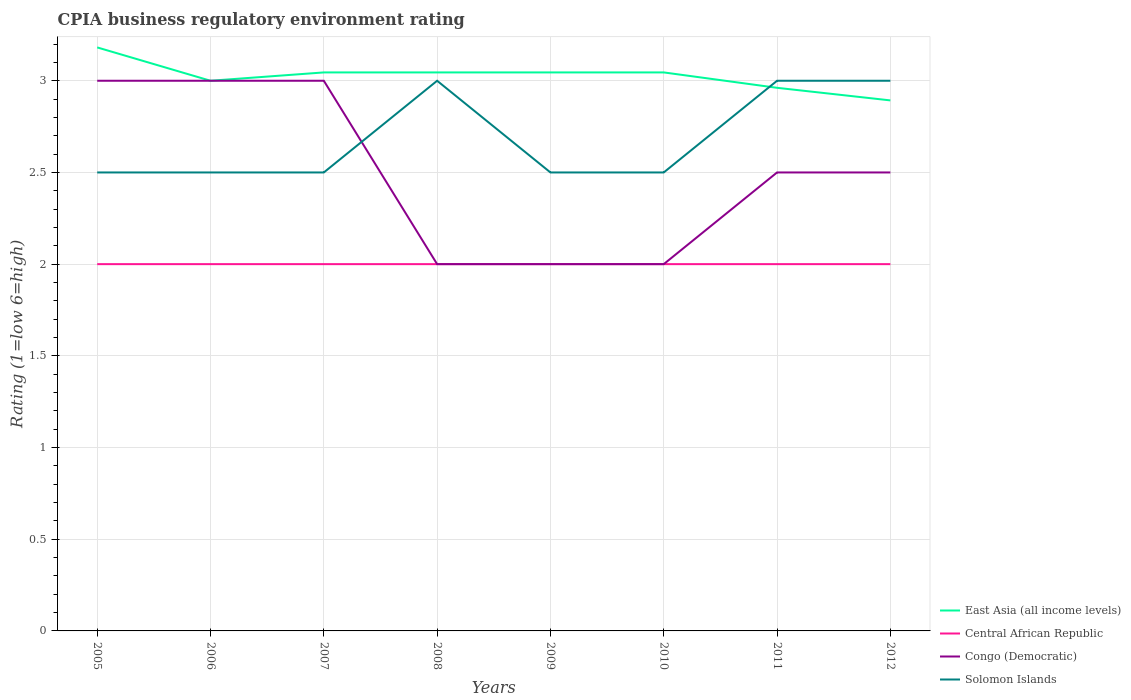How many different coloured lines are there?
Your answer should be compact. 4. Does the line corresponding to Solomon Islands intersect with the line corresponding to East Asia (all income levels)?
Your answer should be compact. Yes. Is the number of lines equal to the number of legend labels?
Your answer should be very brief. Yes. Across all years, what is the maximum CPIA rating in Central African Republic?
Keep it short and to the point. 2. In which year was the CPIA rating in Solomon Islands maximum?
Ensure brevity in your answer.  2005. What is the total CPIA rating in East Asia (all income levels) in the graph?
Your answer should be very brief. -0.05. What is the difference between the highest and the lowest CPIA rating in Solomon Islands?
Keep it short and to the point. 3. Is the CPIA rating in Solomon Islands strictly greater than the CPIA rating in Congo (Democratic) over the years?
Make the answer very short. No. Does the graph contain any zero values?
Give a very brief answer. No. Does the graph contain grids?
Offer a terse response. Yes. What is the title of the graph?
Provide a short and direct response. CPIA business regulatory environment rating. Does "Sri Lanka" appear as one of the legend labels in the graph?
Provide a succinct answer. No. What is the Rating (1=low 6=high) of East Asia (all income levels) in 2005?
Your answer should be very brief. 3.18. What is the Rating (1=low 6=high) of Solomon Islands in 2005?
Your answer should be very brief. 2.5. What is the Rating (1=low 6=high) of East Asia (all income levels) in 2006?
Provide a short and direct response. 3. What is the Rating (1=low 6=high) in Congo (Democratic) in 2006?
Provide a short and direct response. 3. What is the Rating (1=low 6=high) in Solomon Islands in 2006?
Your response must be concise. 2.5. What is the Rating (1=low 6=high) of East Asia (all income levels) in 2007?
Give a very brief answer. 3.05. What is the Rating (1=low 6=high) of Solomon Islands in 2007?
Offer a very short reply. 2.5. What is the Rating (1=low 6=high) of East Asia (all income levels) in 2008?
Your response must be concise. 3.05. What is the Rating (1=low 6=high) in Central African Republic in 2008?
Offer a very short reply. 2. What is the Rating (1=low 6=high) in Congo (Democratic) in 2008?
Your answer should be very brief. 2. What is the Rating (1=low 6=high) in East Asia (all income levels) in 2009?
Keep it short and to the point. 3.05. What is the Rating (1=low 6=high) in East Asia (all income levels) in 2010?
Keep it short and to the point. 3.05. What is the Rating (1=low 6=high) of Solomon Islands in 2010?
Your answer should be compact. 2.5. What is the Rating (1=low 6=high) in East Asia (all income levels) in 2011?
Offer a terse response. 2.96. What is the Rating (1=low 6=high) of East Asia (all income levels) in 2012?
Offer a terse response. 2.89. What is the Rating (1=low 6=high) in Central African Republic in 2012?
Ensure brevity in your answer.  2. What is the Rating (1=low 6=high) in Solomon Islands in 2012?
Keep it short and to the point. 3. Across all years, what is the maximum Rating (1=low 6=high) in East Asia (all income levels)?
Offer a terse response. 3.18. Across all years, what is the maximum Rating (1=low 6=high) of Central African Republic?
Make the answer very short. 2. Across all years, what is the maximum Rating (1=low 6=high) in Congo (Democratic)?
Your response must be concise. 3. Across all years, what is the minimum Rating (1=low 6=high) in East Asia (all income levels)?
Offer a very short reply. 2.89. Across all years, what is the minimum Rating (1=low 6=high) of Central African Republic?
Give a very brief answer. 2. What is the total Rating (1=low 6=high) of East Asia (all income levels) in the graph?
Provide a short and direct response. 24.22. What is the total Rating (1=low 6=high) in Central African Republic in the graph?
Give a very brief answer. 16. What is the difference between the Rating (1=low 6=high) of East Asia (all income levels) in 2005 and that in 2006?
Offer a very short reply. 0.18. What is the difference between the Rating (1=low 6=high) in Congo (Democratic) in 2005 and that in 2006?
Offer a terse response. 0. What is the difference between the Rating (1=low 6=high) of East Asia (all income levels) in 2005 and that in 2007?
Make the answer very short. 0.14. What is the difference between the Rating (1=low 6=high) in Central African Republic in 2005 and that in 2007?
Provide a short and direct response. 0. What is the difference between the Rating (1=low 6=high) of Congo (Democratic) in 2005 and that in 2007?
Your answer should be compact. 0. What is the difference between the Rating (1=low 6=high) in East Asia (all income levels) in 2005 and that in 2008?
Make the answer very short. 0.14. What is the difference between the Rating (1=low 6=high) of Solomon Islands in 2005 and that in 2008?
Provide a succinct answer. -0.5. What is the difference between the Rating (1=low 6=high) in East Asia (all income levels) in 2005 and that in 2009?
Your answer should be very brief. 0.14. What is the difference between the Rating (1=low 6=high) of Central African Republic in 2005 and that in 2009?
Give a very brief answer. 0. What is the difference between the Rating (1=low 6=high) of Congo (Democratic) in 2005 and that in 2009?
Keep it short and to the point. 1. What is the difference between the Rating (1=low 6=high) of Solomon Islands in 2005 and that in 2009?
Ensure brevity in your answer.  0. What is the difference between the Rating (1=low 6=high) in East Asia (all income levels) in 2005 and that in 2010?
Offer a very short reply. 0.14. What is the difference between the Rating (1=low 6=high) of East Asia (all income levels) in 2005 and that in 2011?
Offer a very short reply. 0.22. What is the difference between the Rating (1=low 6=high) of Solomon Islands in 2005 and that in 2011?
Provide a succinct answer. -0.5. What is the difference between the Rating (1=low 6=high) in East Asia (all income levels) in 2005 and that in 2012?
Keep it short and to the point. 0.29. What is the difference between the Rating (1=low 6=high) of Congo (Democratic) in 2005 and that in 2012?
Your answer should be very brief. 0.5. What is the difference between the Rating (1=low 6=high) in Solomon Islands in 2005 and that in 2012?
Your answer should be very brief. -0.5. What is the difference between the Rating (1=low 6=high) in East Asia (all income levels) in 2006 and that in 2007?
Your answer should be compact. -0.05. What is the difference between the Rating (1=low 6=high) of Central African Republic in 2006 and that in 2007?
Keep it short and to the point. 0. What is the difference between the Rating (1=low 6=high) of Congo (Democratic) in 2006 and that in 2007?
Offer a very short reply. 0. What is the difference between the Rating (1=low 6=high) of East Asia (all income levels) in 2006 and that in 2008?
Your response must be concise. -0.05. What is the difference between the Rating (1=low 6=high) of Congo (Democratic) in 2006 and that in 2008?
Your answer should be compact. 1. What is the difference between the Rating (1=low 6=high) in Solomon Islands in 2006 and that in 2008?
Give a very brief answer. -0.5. What is the difference between the Rating (1=low 6=high) in East Asia (all income levels) in 2006 and that in 2009?
Ensure brevity in your answer.  -0.05. What is the difference between the Rating (1=low 6=high) of Central African Republic in 2006 and that in 2009?
Offer a very short reply. 0. What is the difference between the Rating (1=low 6=high) in Congo (Democratic) in 2006 and that in 2009?
Ensure brevity in your answer.  1. What is the difference between the Rating (1=low 6=high) of Solomon Islands in 2006 and that in 2009?
Give a very brief answer. 0. What is the difference between the Rating (1=low 6=high) of East Asia (all income levels) in 2006 and that in 2010?
Your answer should be compact. -0.05. What is the difference between the Rating (1=low 6=high) in Central African Republic in 2006 and that in 2010?
Ensure brevity in your answer.  0. What is the difference between the Rating (1=low 6=high) of East Asia (all income levels) in 2006 and that in 2011?
Your response must be concise. 0.04. What is the difference between the Rating (1=low 6=high) of Central African Republic in 2006 and that in 2011?
Your answer should be compact. 0. What is the difference between the Rating (1=low 6=high) in Congo (Democratic) in 2006 and that in 2011?
Your answer should be compact. 0.5. What is the difference between the Rating (1=low 6=high) of Solomon Islands in 2006 and that in 2011?
Offer a very short reply. -0.5. What is the difference between the Rating (1=low 6=high) in East Asia (all income levels) in 2006 and that in 2012?
Your answer should be very brief. 0.11. What is the difference between the Rating (1=low 6=high) of Solomon Islands in 2006 and that in 2012?
Ensure brevity in your answer.  -0.5. What is the difference between the Rating (1=low 6=high) of East Asia (all income levels) in 2007 and that in 2008?
Your answer should be very brief. 0. What is the difference between the Rating (1=low 6=high) of Solomon Islands in 2007 and that in 2008?
Give a very brief answer. -0.5. What is the difference between the Rating (1=low 6=high) of Central African Republic in 2007 and that in 2009?
Give a very brief answer. 0. What is the difference between the Rating (1=low 6=high) in Congo (Democratic) in 2007 and that in 2009?
Ensure brevity in your answer.  1. What is the difference between the Rating (1=low 6=high) of Solomon Islands in 2007 and that in 2009?
Your response must be concise. 0. What is the difference between the Rating (1=low 6=high) of East Asia (all income levels) in 2007 and that in 2010?
Make the answer very short. 0. What is the difference between the Rating (1=low 6=high) of Congo (Democratic) in 2007 and that in 2010?
Give a very brief answer. 1. What is the difference between the Rating (1=low 6=high) of Solomon Islands in 2007 and that in 2010?
Keep it short and to the point. 0. What is the difference between the Rating (1=low 6=high) of East Asia (all income levels) in 2007 and that in 2011?
Provide a short and direct response. 0.08. What is the difference between the Rating (1=low 6=high) of Congo (Democratic) in 2007 and that in 2011?
Ensure brevity in your answer.  0.5. What is the difference between the Rating (1=low 6=high) in East Asia (all income levels) in 2007 and that in 2012?
Your answer should be compact. 0.15. What is the difference between the Rating (1=low 6=high) of Congo (Democratic) in 2007 and that in 2012?
Offer a terse response. 0.5. What is the difference between the Rating (1=low 6=high) of Solomon Islands in 2007 and that in 2012?
Your answer should be very brief. -0.5. What is the difference between the Rating (1=low 6=high) in East Asia (all income levels) in 2008 and that in 2009?
Provide a short and direct response. 0. What is the difference between the Rating (1=low 6=high) in Central African Republic in 2008 and that in 2009?
Provide a succinct answer. 0. What is the difference between the Rating (1=low 6=high) of Congo (Democratic) in 2008 and that in 2009?
Ensure brevity in your answer.  0. What is the difference between the Rating (1=low 6=high) of Solomon Islands in 2008 and that in 2009?
Offer a terse response. 0.5. What is the difference between the Rating (1=low 6=high) in East Asia (all income levels) in 2008 and that in 2010?
Provide a succinct answer. 0. What is the difference between the Rating (1=low 6=high) of Congo (Democratic) in 2008 and that in 2010?
Make the answer very short. 0. What is the difference between the Rating (1=low 6=high) of Solomon Islands in 2008 and that in 2010?
Your answer should be compact. 0.5. What is the difference between the Rating (1=low 6=high) in East Asia (all income levels) in 2008 and that in 2011?
Your answer should be very brief. 0.08. What is the difference between the Rating (1=low 6=high) in East Asia (all income levels) in 2008 and that in 2012?
Give a very brief answer. 0.15. What is the difference between the Rating (1=low 6=high) in Congo (Democratic) in 2008 and that in 2012?
Ensure brevity in your answer.  -0.5. What is the difference between the Rating (1=low 6=high) in East Asia (all income levels) in 2009 and that in 2010?
Your response must be concise. 0. What is the difference between the Rating (1=low 6=high) of East Asia (all income levels) in 2009 and that in 2011?
Give a very brief answer. 0.08. What is the difference between the Rating (1=low 6=high) of Central African Republic in 2009 and that in 2011?
Offer a very short reply. 0. What is the difference between the Rating (1=low 6=high) of Solomon Islands in 2009 and that in 2011?
Your answer should be very brief. -0.5. What is the difference between the Rating (1=low 6=high) in East Asia (all income levels) in 2009 and that in 2012?
Give a very brief answer. 0.15. What is the difference between the Rating (1=low 6=high) in Central African Republic in 2009 and that in 2012?
Your answer should be compact. 0. What is the difference between the Rating (1=low 6=high) of Congo (Democratic) in 2009 and that in 2012?
Provide a succinct answer. -0.5. What is the difference between the Rating (1=low 6=high) of Solomon Islands in 2009 and that in 2012?
Ensure brevity in your answer.  -0.5. What is the difference between the Rating (1=low 6=high) in East Asia (all income levels) in 2010 and that in 2011?
Keep it short and to the point. 0.08. What is the difference between the Rating (1=low 6=high) of East Asia (all income levels) in 2010 and that in 2012?
Keep it short and to the point. 0.15. What is the difference between the Rating (1=low 6=high) of Central African Republic in 2010 and that in 2012?
Make the answer very short. 0. What is the difference between the Rating (1=low 6=high) in Solomon Islands in 2010 and that in 2012?
Provide a succinct answer. -0.5. What is the difference between the Rating (1=low 6=high) in East Asia (all income levels) in 2011 and that in 2012?
Ensure brevity in your answer.  0.07. What is the difference between the Rating (1=low 6=high) in East Asia (all income levels) in 2005 and the Rating (1=low 6=high) in Central African Republic in 2006?
Offer a very short reply. 1.18. What is the difference between the Rating (1=low 6=high) in East Asia (all income levels) in 2005 and the Rating (1=low 6=high) in Congo (Democratic) in 2006?
Offer a very short reply. 0.18. What is the difference between the Rating (1=low 6=high) in East Asia (all income levels) in 2005 and the Rating (1=low 6=high) in Solomon Islands in 2006?
Provide a short and direct response. 0.68. What is the difference between the Rating (1=low 6=high) of Central African Republic in 2005 and the Rating (1=low 6=high) of Solomon Islands in 2006?
Keep it short and to the point. -0.5. What is the difference between the Rating (1=low 6=high) in East Asia (all income levels) in 2005 and the Rating (1=low 6=high) in Central African Republic in 2007?
Your answer should be very brief. 1.18. What is the difference between the Rating (1=low 6=high) in East Asia (all income levels) in 2005 and the Rating (1=low 6=high) in Congo (Democratic) in 2007?
Give a very brief answer. 0.18. What is the difference between the Rating (1=low 6=high) in East Asia (all income levels) in 2005 and the Rating (1=low 6=high) in Solomon Islands in 2007?
Ensure brevity in your answer.  0.68. What is the difference between the Rating (1=low 6=high) in Central African Republic in 2005 and the Rating (1=low 6=high) in Solomon Islands in 2007?
Provide a short and direct response. -0.5. What is the difference between the Rating (1=low 6=high) of Congo (Democratic) in 2005 and the Rating (1=low 6=high) of Solomon Islands in 2007?
Your response must be concise. 0.5. What is the difference between the Rating (1=low 6=high) in East Asia (all income levels) in 2005 and the Rating (1=low 6=high) in Central African Republic in 2008?
Keep it short and to the point. 1.18. What is the difference between the Rating (1=low 6=high) in East Asia (all income levels) in 2005 and the Rating (1=low 6=high) in Congo (Democratic) in 2008?
Your response must be concise. 1.18. What is the difference between the Rating (1=low 6=high) of East Asia (all income levels) in 2005 and the Rating (1=low 6=high) of Solomon Islands in 2008?
Keep it short and to the point. 0.18. What is the difference between the Rating (1=low 6=high) of Central African Republic in 2005 and the Rating (1=low 6=high) of Congo (Democratic) in 2008?
Provide a succinct answer. 0. What is the difference between the Rating (1=low 6=high) in Congo (Democratic) in 2005 and the Rating (1=low 6=high) in Solomon Islands in 2008?
Give a very brief answer. 0. What is the difference between the Rating (1=low 6=high) in East Asia (all income levels) in 2005 and the Rating (1=low 6=high) in Central African Republic in 2009?
Your answer should be compact. 1.18. What is the difference between the Rating (1=low 6=high) in East Asia (all income levels) in 2005 and the Rating (1=low 6=high) in Congo (Democratic) in 2009?
Give a very brief answer. 1.18. What is the difference between the Rating (1=low 6=high) in East Asia (all income levels) in 2005 and the Rating (1=low 6=high) in Solomon Islands in 2009?
Keep it short and to the point. 0.68. What is the difference between the Rating (1=low 6=high) of Central African Republic in 2005 and the Rating (1=low 6=high) of Congo (Democratic) in 2009?
Your response must be concise. 0. What is the difference between the Rating (1=low 6=high) of Central African Republic in 2005 and the Rating (1=low 6=high) of Solomon Islands in 2009?
Offer a terse response. -0.5. What is the difference between the Rating (1=low 6=high) of East Asia (all income levels) in 2005 and the Rating (1=low 6=high) of Central African Republic in 2010?
Provide a succinct answer. 1.18. What is the difference between the Rating (1=low 6=high) of East Asia (all income levels) in 2005 and the Rating (1=low 6=high) of Congo (Democratic) in 2010?
Offer a terse response. 1.18. What is the difference between the Rating (1=low 6=high) in East Asia (all income levels) in 2005 and the Rating (1=low 6=high) in Solomon Islands in 2010?
Your answer should be very brief. 0.68. What is the difference between the Rating (1=low 6=high) of Central African Republic in 2005 and the Rating (1=low 6=high) of Congo (Democratic) in 2010?
Provide a short and direct response. 0. What is the difference between the Rating (1=low 6=high) of Central African Republic in 2005 and the Rating (1=low 6=high) of Solomon Islands in 2010?
Your answer should be very brief. -0.5. What is the difference between the Rating (1=low 6=high) in East Asia (all income levels) in 2005 and the Rating (1=low 6=high) in Central African Republic in 2011?
Your answer should be very brief. 1.18. What is the difference between the Rating (1=low 6=high) of East Asia (all income levels) in 2005 and the Rating (1=low 6=high) of Congo (Democratic) in 2011?
Ensure brevity in your answer.  0.68. What is the difference between the Rating (1=low 6=high) of East Asia (all income levels) in 2005 and the Rating (1=low 6=high) of Solomon Islands in 2011?
Your response must be concise. 0.18. What is the difference between the Rating (1=low 6=high) in Central African Republic in 2005 and the Rating (1=low 6=high) in Solomon Islands in 2011?
Offer a terse response. -1. What is the difference between the Rating (1=low 6=high) of Congo (Democratic) in 2005 and the Rating (1=low 6=high) of Solomon Islands in 2011?
Offer a terse response. 0. What is the difference between the Rating (1=low 6=high) in East Asia (all income levels) in 2005 and the Rating (1=low 6=high) in Central African Republic in 2012?
Provide a short and direct response. 1.18. What is the difference between the Rating (1=low 6=high) in East Asia (all income levels) in 2005 and the Rating (1=low 6=high) in Congo (Democratic) in 2012?
Provide a succinct answer. 0.68. What is the difference between the Rating (1=low 6=high) of East Asia (all income levels) in 2005 and the Rating (1=low 6=high) of Solomon Islands in 2012?
Your answer should be compact. 0.18. What is the difference between the Rating (1=low 6=high) in Congo (Democratic) in 2005 and the Rating (1=low 6=high) in Solomon Islands in 2012?
Keep it short and to the point. 0. What is the difference between the Rating (1=low 6=high) of East Asia (all income levels) in 2006 and the Rating (1=low 6=high) of Central African Republic in 2007?
Ensure brevity in your answer.  1. What is the difference between the Rating (1=low 6=high) in East Asia (all income levels) in 2006 and the Rating (1=low 6=high) in Congo (Democratic) in 2007?
Provide a short and direct response. 0. What is the difference between the Rating (1=low 6=high) of East Asia (all income levels) in 2006 and the Rating (1=low 6=high) of Solomon Islands in 2007?
Ensure brevity in your answer.  0.5. What is the difference between the Rating (1=low 6=high) of Central African Republic in 2006 and the Rating (1=low 6=high) of Congo (Democratic) in 2007?
Offer a terse response. -1. What is the difference between the Rating (1=low 6=high) of Congo (Democratic) in 2006 and the Rating (1=low 6=high) of Solomon Islands in 2007?
Offer a very short reply. 0.5. What is the difference between the Rating (1=low 6=high) in East Asia (all income levels) in 2006 and the Rating (1=low 6=high) in Central African Republic in 2008?
Your answer should be compact. 1. What is the difference between the Rating (1=low 6=high) in East Asia (all income levels) in 2006 and the Rating (1=low 6=high) in Congo (Democratic) in 2008?
Make the answer very short. 1. What is the difference between the Rating (1=low 6=high) in East Asia (all income levels) in 2006 and the Rating (1=low 6=high) in Solomon Islands in 2008?
Offer a terse response. 0. What is the difference between the Rating (1=low 6=high) in Central African Republic in 2006 and the Rating (1=low 6=high) in Congo (Democratic) in 2008?
Your answer should be compact. 0. What is the difference between the Rating (1=low 6=high) of Central African Republic in 2006 and the Rating (1=low 6=high) of Solomon Islands in 2008?
Make the answer very short. -1. What is the difference between the Rating (1=low 6=high) in Congo (Democratic) in 2006 and the Rating (1=low 6=high) in Solomon Islands in 2008?
Provide a short and direct response. 0. What is the difference between the Rating (1=low 6=high) of East Asia (all income levels) in 2006 and the Rating (1=low 6=high) of Central African Republic in 2009?
Your answer should be very brief. 1. What is the difference between the Rating (1=low 6=high) in East Asia (all income levels) in 2006 and the Rating (1=low 6=high) in Congo (Democratic) in 2009?
Make the answer very short. 1. What is the difference between the Rating (1=low 6=high) in Central African Republic in 2006 and the Rating (1=low 6=high) in Solomon Islands in 2009?
Give a very brief answer. -0.5. What is the difference between the Rating (1=low 6=high) in East Asia (all income levels) in 2006 and the Rating (1=low 6=high) in Central African Republic in 2010?
Offer a very short reply. 1. What is the difference between the Rating (1=low 6=high) of East Asia (all income levels) in 2006 and the Rating (1=low 6=high) of Central African Republic in 2011?
Keep it short and to the point. 1. What is the difference between the Rating (1=low 6=high) in East Asia (all income levels) in 2006 and the Rating (1=low 6=high) in Solomon Islands in 2011?
Offer a terse response. 0. What is the difference between the Rating (1=low 6=high) of Central African Republic in 2006 and the Rating (1=low 6=high) of Congo (Democratic) in 2011?
Give a very brief answer. -0.5. What is the difference between the Rating (1=low 6=high) in Congo (Democratic) in 2006 and the Rating (1=low 6=high) in Solomon Islands in 2011?
Offer a very short reply. 0. What is the difference between the Rating (1=low 6=high) in East Asia (all income levels) in 2006 and the Rating (1=low 6=high) in Central African Republic in 2012?
Give a very brief answer. 1. What is the difference between the Rating (1=low 6=high) in East Asia (all income levels) in 2006 and the Rating (1=low 6=high) in Congo (Democratic) in 2012?
Your answer should be compact. 0.5. What is the difference between the Rating (1=low 6=high) in Central African Republic in 2006 and the Rating (1=low 6=high) in Congo (Democratic) in 2012?
Offer a terse response. -0.5. What is the difference between the Rating (1=low 6=high) in Central African Republic in 2006 and the Rating (1=low 6=high) in Solomon Islands in 2012?
Your response must be concise. -1. What is the difference between the Rating (1=low 6=high) in Congo (Democratic) in 2006 and the Rating (1=low 6=high) in Solomon Islands in 2012?
Provide a succinct answer. 0. What is the difference between the Rating (1=low 6=high) of East Asia (all income levels) in 2007 and the Rating (1=low 6=high) of Central African Republic in 2008?
Give a very brief answer. 1.05. What is the difference between the Rating (1=low 6=high) of East Asia (all income levels) in 2007 and the Rating (1=low 6=high) of Congo (Democratic) in 2008?
Make the answer very short. 1.05. What is the difference between the Rating (1=low 6=high) of East Asia (all income levels) in 2007 and the Rating (1=low 6=high) of Solomon Islands in 2008?
Offer a very short reply. 0.05. What is the difference between the Rating (1=low 6=high) of Central African Republic in 2007 and the Rating (1=low 6=high) of Solomon Islands in 2008?
Your response must be concise. -1. What is the difference between the Rating (1=low 6=high) of East Asia (all income levels) in 2007 and the Rating (1=low 6=high) of Central African Republic in 2009?
Give a very brief answer. 1.05. What is the difference between the Rating (1=low 6=high) in East Asia (all income levels) in 2007 and the Rating (1=low 6=high) in Congo (Democratic) in 2009?
Ensure brevity in your answer.  1.05. What is the difference between the Rating (1=low 6=high) in East Asia (all income levels) in 2007 and the Rating (1=low 6=high) in Solomon Islands in 2009?
Your response must be concise. 0.55. What is the difference between the Rating (1=low 6=high) in Congo (Democratic) in 2007 and the Rating (1=low 6=high) in Solomon Islands in 2009?
Provide a succinct answer. 0.5. What is the difference between the Rating (1=low 6=high) in East Asia (all income levels) in 2007 and the Rating (1=low 6=high) in Central African Republic in 2010?
Ensure brevity in your answer.  1.05. What is the difference between the Rating (1=low 6=high) of East Asia (all income levels) in 2007 and the Rating (1=low 6=high) of Congo (Democratic) in 2010?
Ensure brevity in your answer.  1.05. What is the difference between the Rating (1=low 6=high) in East Asia (all income levels) in 2007 and the Rating (1=low 6=high) in Solomon Islands in 2010?
Offer a terse response. 0.55. What is the difference between the Rating (1=low 6=high) of Central African Republic in 2007 and the Rating (1=low 6=high) of Congo (Democratic) in 2010?
Keep it short and to the point. 0. What is the difference between the Rating (1=low 6=high) of Central African Republic in 2007 and the Rating (1=low 6=high) of Solomon Islands in 2010?
Provide a succinct answer. -0.5. What is the difference between the Rating (1=low 6=high) of Congo (Democratic) in 2007 and the Rating (1=low 6=high) of Solomon Islands in 2010?
Offer a terse response. 0.5. What is the difference between the Rating (1=low 6=high) in East Asia (all income levels) in 2007 and the Rating (1=low 6=high) in Central African Republic in 2011?
Your answer should be very brief. 1.05. What is the difference between the Rating (1=low 6=high) of East Asia (all income levels) in 2007 and the Rating (1=low 6=high) of Congo (Democratic) in 2011?
Make the answer very short. 0.55. What is the difference between the Rating (1=low 6=high) in East Asia (all income levels) in 2007 and the Rating (1=low 6=high) in Solomon Islands in 2011?
Provide a short and direct response. 0.05. What is the difference between the Rating (1=low 6=high) of East Asia (all income levels) in 2007 and the Rating (1=low 6=high) of Central African Republic in 2012?
Provide a succinct answer. 1.05. What is the difference between the Rating (1=low 6=high) of East Asia (all income levels) in 2007 and the Rating (1=low 6=high) of Congo (Democratic) in 2012?
Ensure brevity in your answer.  0.55. What is the difference between the Rating (1=low 6=high) in East Asia (all income levels) in 2007 and the Rating (1=low 6=high) in Solomon Islands in 2012?
Give a very brief answer. 0.05. What is the difference between the Rating (1=low 6=high) in Central African Republic in 2007 and the Rating (1=low 6=high) in Congo (Democratic) in 2012?
Make the answer very short. -0.5. What is the difference between the Rating (1=low 6=high) in East Asia (all income levels) in 2008 and the Rating (1=low 6=high) in Central African Republic in 2009?
Offer a very short reply. 1.05. What is the difference between the Rating (1=low 6=high) in East Asia (all income levels) in 2008 and the Rating (1=low 6=high) in Congo (Democratic) in 2009?
Offer a terse response. 1.05. What is the difference between the Rating (1=low 6=high) of East Asia (all income levels) in 2008 and the Rating (1=low 6=high) of Solomon Islands in 2009?
Your answer should be very brief. 0.55. What is the difference between the Rating (1=low 6=high) of Central African Republic in 2008 and the Rating (1=low 6=high) of Congo (Democratic) in 2009?
Ensure brevity in your answer.  0. What is the difference between the Rating (1=low 6=high) in Central African Republic in 2008 and the Rating (1=low 6=high) in Solomon Islands in 2009?
Offer a terse response. -0.5. What is the difference between the Rating (1=low 6=high) in Congo (Democratic) in 2008 and the Rating (1=low 6=high) in Solomon Islands in 2009?
Make the answer very short. -0.5. What is the difference between the Rating (1=low 6=high) in East Asia (all income levels) in 2008 and the Rating (1=low 6=high) in Central African Republic in 2010?
Provide a short and direct response. 1.05. What is the difference between the Rating (1=low 6=high) of East Asia (all income levels) in 2008 and the Rating (1=low 6=high) of Congo (Democratic) in 2010?
Provide a short and direct response. 1.05. What is the difference between the Rating (1=low 6=high) in East Asia (all income levels) in 2008 and the Rating (1=low 6=high) in Solomon Islands in 2010?
Offer a terse response. 0.55. What is the difference between the Rating (1=low 6=high) in Central African Republic in 2008 and the Rating (1=low 6=high) in Solomon Islands in 2010?
Your answer should be compact. -0.5. What is the difference between the Rating (1=low 6=high) in Congo (Democratic) in 2008 and the Rating (1=low 6=high) in Solomon Islands in 2010?
Ensure brevity in your answer.  -0.5. What is the difference between the Rating (1=low 6=high) in East Asia (all income levels) in 2008 and the Rating (1=low 6=high) in Central African Republic in 2011?
Provide a succinct answer. 1.05. What is the difference between the Rating (1=low 6=high) in East Asia (all income levels) in 2008 and the Rating (1=low 6=high) in Congo (Democratic) in 2011?
Keep it short and to the point. 0.55. What is the difference between the Rating (1=low 6=high) of East Asia (all income levels) in 2008 and the Rating (1=low 6=high) of Solomon Islands in 2011?
Offer a terse response. 0.05. What is the difference between the Rating (1=low 6=high) in Central African Republic in 2008 and the Rating (1=low 6=high) in Solomon Islands in 2011?
Your response must be concise. -1. What is the difference between the Rating (1=low 6=high) in East Asia (all income levels) in 2008 and the Rating (1=low 6=high) in Central African Republic in 2012?
Your answer should be very brief. 1.05. What is the difference between the Rating (1=low 6=high) of East Asia (all income levels) in 2008 and the Rating (1=low 6=high) of Congo (Democratic) in 2012?
Ensure brevity in your answer.  0.55. What is the difference between the Rating (1=low 6=high) of East Asia (all income levels) in 2008 and the Rating (1=low 6=high) of Solomon Islands in 2012?
Provide a succinct answer. 0.05. What is the difference between the Rating (1=low 6=high) of Central African Republic in 2008 and the Rating (1=low 6=high) of Congo (Democratic) in 2012?
Provide a short and direct response. -0.5. What is the difference between the Rating (1=low 6=high) of Central African Republic in 2008 and the Rating (1=low 6=high) of Solomon Islands in 2012?
Offer a terse response. -1. What is the difference between the Rating (1=low 6=high) of East Asia (all income levels) in 2009 and the Rating (1=low 6=high) of Central African Republic in 2010?
Keep it short and to the point. 1.05. What is the difference between the Rating (1=low 6=high) of East Asia (all income levels) in 2009 and the Rating (1=low 6=high) of Congo (Democratic) in 2010?
Make the answer very short. 1.05. What is the difference between the Rating (1=low 6=high) in East Asia (all income levels) in 2009 and the Rating (1=low 6=high) in Solomon Islands in 2010?
Keep it short and to the point. 0.55. What is the difference between the Rating (1=low 6=high) in Central African Republic in 2009 and the Rating (1=low 6=high) in Congo (Democratic) in 2010?
Your response must be concise. 0. What is the difference between the Rating (1=low 6=high) in Central African Republic in 2009 and the Rating (1=low 6=high) in Solomon Islands in 2010?
Offer a very short reply. -0.5. What is the difference between the Rating (1=low 6=high) in Congo (Democratic) in 2009 and the Rating (1=low 6=high) in Solomon Islands in 2010?
Your answer should be very brief. -0.5. What is the difference between the Rating (1=low 6=high) of East Asia (all income levels) in 2009 and the Rating (1=low 6=high) of Central African Republic in 2011?
Offer a very short reply. 1.05. What is the difference between the Rating (1=low 6=high) in East Asia (all income levels) in 2009 and the Rating (1=low 6=high) in Congo (Democratic) in 2011?
Provide a succinct answer. 0.55. What is the difference between the Rating (1=low 6=high) of East Asia (all income levels) in 2009 and the Rating (1=low 6=high) of Solomon Islands in 2011?
Ensure brevity in your answer.  0.05. What is the difference between the Rating (1=low 6=high) in Central African Republic in 2009 and the Rating (1=low 6=high) in Congo (Democratic) in 2011?
Offer a terse response. -0.5. What is the difference between the Rating (1=low 6=high) in Central African Republic in 2009 and the Rating (1=low 6=high) in Solomon Islands in 2011?
Make the answer very short. -1. What is the difference between the Rating (1=low 6=high) of Congo (Democratic) in 2009 and the Rating (1=low 6=high) of Solomon Islands in 2011?
Your answer should be very brief. -1. What is the difference between the Rating (1=low 6=high) in East Asia (all income levels) in 2009 and the Rating (1=low 6=high) in Central African Republic in 2012?
Your response must be concise. 1.05. What is the difference between the Rating (1=low 6=high) of East Asia (all income levels) in 2009 and the Rating (1=low 6=high) of Congo (Democratic) in 2012?
Your answer should be very brief. 0.55. What is the difference between the Rating (1=low 6=high) of East Asia (all income levels) in 2009 and the Rating (1=low 6=high) of Solomon Islands in 2012?
Your response must be concise. 0.05. What is the difference between the Rating (1=low 6=high) of Central African Republic in 2009 and the Rating (1=low 6=high) of Solomon Islands in 2012?
Ensure brevity in your answer.  -1. What is the difference between the Rating (1=low 6=high) in East Asia (all income levels) in 2010 and the Rating (1=low 6=high) in Central African Republic in 2011?
Give a very brief answer. 1.05. What is the difference between the Rating (1=low 6=high) of East Asia (all income levels) in 2010 and the Rating (1=low 6=high) of Congo (Democratic) in 2011?
Make the answer very short. 0.55. What is the difference between the Rating (1=low 6=high) of East Asia (all income levels) in 2010 and the Rating (1=low 6=high) of Solomon Islands in 2011?
Make the answer very short. 0.05. What is the difference between the Rating (1=low 6=high) in Central African Republic in 2010 and the Rating (1=low 6=high) in Solomon Islands in 2011?
Offer a terse response. -1. What is the difference between the Rating (1=low 6=high) in East Asia (all income levels) in 2010 and the Rating (1=low 6=high) in Central African Republic in 2012?
Provide a short and direct response. 1.05. What is the difference between the Rating (1=low 6=high) in East Asia (all income levels) in 2010 and the Rating (1=low 6=high) in Congo (Democratic) in 2012?
Offer a terse response. 0.55. What is the difference between the Rating (1=low 6=high) in East Asia (all income levels) in 2010 and the Rating (1=low 6=high) in Solomon Islands in 2012?
Provide a short and direct response. 0.05. What is the difference between the Rating (1=low 6=high) in Central African Republic in 2010 and the Rating (1=low 6=high) in Congo (Democratic) in 2012?
Your response must be concise. -0.5. What is the difference between the Rating (1=low 6=high) in East Asia (all income levels) in 2011 and the Rating (1=low 6=high) in Central African Republic in 2012?
Ensure brevity in your answer.  0.96. What is the difference between the Rating (1=low 6=high) of East Asia (all income levels) in 2011 and the Rating (1=low 6=high) of Congo (Democratic) in 2012?
Your answer should be compact. 0.46. What is the difference between the Rating (1=low 6=high) of East Asia (all income levels) in 2011 and the Rating (1=low 6=high) of Solomon Islands in 2012?
Offer a very short reply. -0.04. What is the difference between the Rating (1=low 6=high) of Central African Republic in 2011 and the Rating (1=low 6=high) of Congo (Democratic) in 2012?
Your answer should be compact. -0.5. What is the difference between the Rating (1=low 6=high) in Central African Republic in 2011 and the Rating (1=low 6=high) in Solomon Islands in 2012?
Provide a short and direct response. -1. What is the difference between the Rating (1=low 6=high) of Congo (Democratic) in 2011 and the Rating (1=low 6=high) of Solomon Islands in 2012?
Your answer should be compact. -0.5. What is the average Rating (1=low 6=high) in East Asia (all income levels) per year?
Provide a succinct answer. 3.03. What is the average Rating (1=low 6=high) in Central African Republic per year?
Give a very brief answer. 2. What is the average Rating (1=low 6=high) in Congo (Democratic) per year?
Offer a terse response. 2.5. What is the average Rating (1=low 6=high) in Solomon Islands per year?
Your answer should be very brief. 2.69. In the year 2005, what is the difference between the Rating (1=low 6=high) of East Asia (all income levels) and Rating (1=low 6=high) of Central African Republic?
Keep it short and to the point. 1.18. In the year 2005, what is the difference between the Rating (1=low 6=high) in East Asia (all income levels) and Rating (1=low 6=high) in Congo (Democratic)?
Your answer should be compact. 0.18. In the year 2005, what is the difference between the Rating (1=low 6=high) in East Asia (all income levels) and Rating (1=low 6=high) in Solomon Islands?
Offer a terse response. 0.68. In the year 2005, what is the difference between the Rating (1=low 6=high) of Central African Republic and Rating (1=low 6=high) of Solomon Islands?
Offer a terse response. -0.5. In the year 2005, what is the difference between the Rating (1=low 6=high) in Congo (Democratic) and Rating (1=low 6=high) in Solomon Islands?
Your response must be concise. 0.5. In the year 2006, what is the difference between the Rating (1=low 6=high) in East Asia (all income levels) and Rating (1=low 6=high) in Central African Republic?
Your answer should be compact. 1. In the year 2006, what is the difference between the Rating (1=low 6=high) in East Asia (all income levels) and Rating (1=low 6=high) in Congo (Democratic)?
Your answer should be very brief. 0. In the year 2006, what is the difference between the Rating (1=low 6=high) of Central African Republic and Rating (1=low 6=high) of Solomon Islands?
Ensure brevity in your answer.  -0.5. In the year 2006, what is the difference between the Rating (1=low 6=high) of Congo (Democratic) and Rating (1=low 6=high) of Solomon Islands?
Your answer should be very brief. 0.5. In the year 2007, what is the difference between the Rating (1=low 6=high) of East Asia (all income levels) and Rating (1=low 6=high) of Central African Republic?
Provide a succinct answer. 1.05. In the year 2007, what is the difference between the Rating (1=low 6=high) in East Asia (all income levels) and Rating (1=low 6=high) in Congo (Democratic)?
Offer a terse response. 0.05. In the year 2007, what is the difference between the Rating (1=low 6=high) in East Asia (all income levels) and Rating (1=low 6=high) in Solomon Islands?
Provide a short and direct response. 0.55. In the year 2007, what is the difference between the Rating (1=low 6=high) in Congo (Democratic) and Rating (1=low 6=high) in Solomon Islands?
Your response must be concise. 0.5. In the year 2008, what is the difference between the Rating (1=low 6=high) in East Asia (all income levels) and Rating (1=low 6=high) in Central African Republic?
Provide a short and direct response. 1.05. In the year 2008, what is the difference between the Rating (1=low 6=high) of East Asia (all income levels) and Rating (1=low 6=high) of Congo (Democratic)?
Keep it short and to the point. 1.05. In the year 2008, what is the difference between the Rating (1=low 6=high) in East Asia (all income levels) and Rating (1=low 6=high) in Solomon Islands?
Your response must be concise. 0.05. In the year 2008, what is the difference between the Rating (1=low 6=high) of Central African Republic and Rating (1=low 6=high) of Solomon Islands?
Your answer should be compact. -1. In the year 2008, what is the difference between the Rating (1=low 6=high) of Congo (Democratic) and Rating (1=low 6=high) of Solomon Islands?
Make the answer very short. -1. In the year 2009, what is the difference between the Rating (1=low 6=high) of East Asia (all income levels) and Rating (1=low 6=high) of Central African Republic?
Your response must be concise. 1.05. In the year 2009, what is the difference between the Rating (1=low 6=high) in East Asia (all income levels) and Rating (1=low 6=high) in Congo (Democratic)?
Offer a very short reply. 1.05. In the year 2009, what is the difference between the Rating (1=low 6=high) of East Asia (all income levels) and Rating (1=low 6=high) of Solomon Islands?
Offer a very short reply. 0.55. In the year 2009, what is the difference between the Rating (1=low 6=high) of Congo (Democratic) and Rating (1=low 6=high) of Solomon Islands?
Offer a very short reply. -0.5. In the year 2010, what is the difference between the Rating (1=low 6=high) of East Asia (all income levels) and Rating (1=low 6=high) of Central African Republic?
Provide a succinct answer. 1.05. In the year 2010, what is the difference between the Rating (1=low 6=high) in East Asia (all income levels) and Rating (1=low 6=high) in Congo (Democratic)?
Your answer should be compact. 1.05. In the year 2010, what is the difference between the Rating (1=low 6=high) of East Asia (all income levels) and Rating (1=low 6=high) of Solomon Islands?
Ensure brevity in your answer.  0.55. In the year 2010, what is the difference between the Rating (1=low 6=high) of Central African Republic and Rating (1=low 6=high) of Congo (Democratic)?
Make the answer very short. 0. In the year 2010, what is the difference between the Rating (1=low 6=high) of Congo (Democratic) and Rating (1=low 6=high) of Solomon Islands?
Offer a very short reply. -0.5. In the year 2011, what is the difference between the Rating (1=low 6=high) of East Asia (all income levels) and Rating (1=low 6=high) of Central African Republic?
Offer a very short reply. 0.96. In the year 2011, what is the difference between the Rating (1=low 6=high) in East Asia (all income levels) and Rating (1=low 6=high) in Congo (Democratic)?
Give a very brief answer. 0.46. In the year 2011, what is the difference between the Rating (1=low 6=high) in East Asia (all income levels) and Rating (1=low 6=high) in Solomon Islands?
Keep it short and to the point. -0.04. In the year 2011, what is the difference between the Rating (1=low 6=high) of Central African Republic and Rating (1=low 6=high) of Congo (Democratic)?
Your answer should be compact. -0.5. In the year 2011, what is the difference between the Rating (1=low 6=high) in Central African Republic and Rating (1=low 6=high) in Solomon Islands?
Make the answer very short. -1. In the year 2011, what is the difference between the Rating (1=low 6=high) of Congo (Democratic) and Rating (1=low 6=high) of Solomon Islands?
Ensure brevity in your answer.  -0.5. In the year 2012, what is the difference between the Rating (1=low 6=high) in East Asia (all income levels) and Rating (1=low 6=high) in Central African Republic?
Ensure brevity in your answer.  0.89. In the year 2012, what is the difference between the Rating (1=low 6=high) of East Asia (all income levels) and Rating (1=low 6=high) of Congo (Democratic)?
Give a very brief answer. 0.39. In the year 2012, what is the difference between the Rating (1=low 6=high) of East Asia (all income levels) and Rating (1=low 6=high) of Solomon Islands?
Your answer should be very brief. -0.11. In the year 2012, what is the difference between the Rating (1=low 6=high) in Central African Republic and Rating (1=low 6=high) in Congo (Democratic)?
Provide a succinct answer. -0.5. What is the ratio of the Rating (1=low 6=high) of East Asia (all income levels) in 2005 to that in 2006?
Provide a succinct answer. 1.06. What is the ratio of the Rating (1=low 6=high) in Central African Republic in 2005 to that in 2006?
Make the answer very short. 1. What is the ratio of the Rating (1=low 6=high) in East Asia (all income levels) in 2005 to that in 2007?
Keep it short and to the point. 1.04. What is the ratio of the Rating (1=low 6=high) of Central African Republic in 2005 to that in 2007?
Offer a terse response. 1. What is the ratio of the Rating (1=low 6=high) of East Asia (all income levels) in 2005 to that in 2008?
Your answer should be very brief. 1.04. What is the ratio of the Rating (1=low 6=high) in Central African Republic in 2005 to that in 2008?
Provide a succinct answer. 1. What is the ratio of the Rating (1=low 6=high) of Solomon Islands in 2005 to that in 2008?
Offer a terse response. 0.83. What is the ratio of the Rating (1=low 6=high) in East Asia (all income levels) in 2005 to that in 2009?
Make the answer very short. 1.04. What is the ratio of the Rating (1=low 6=high) in East Asia (all income levels) in 2005 to that in 2010?
Your answer should be compact. 1.04. What is the ratio of the Rating (1=low 6=high) in Central African Republic in 2005 to that in 2010?
Your response must be concise. 1. What is the ratio of the Rating (1=low 6=high) of Solomon Islands in 2005 to that in 2010?
Your answer should be very brief. 1. What is the ratio of the Rating (1=low 6=high) in East Asia (all income levels) in 2005 to that in 2011?
Your answer should be compact. 1.07. What is the ratio of the Rating (1=low 6=high) of Congo (Democratic) in 2005 to that in 2011?
Give a very brief answer. 1.2. What is the ratio of the Rating (1=low 6=high) of Solomon Islands in 2005 to that in 2011?
Your answer should be compact. 0.83. What is the ratio of the Rating (1=low 6=high) in East Asia (all income levels) in 2005 to that in 2012?
Give a very brief answer. 1.1. What is the ratio of the Rating (1=low 6=high) of Central African Republic in 2005 to that in 2012?
Make the answer very short. 1. What is the ratio of the Rating (1=low 6=high) in Congo (Democratic) in 2005 to that in 2012?
Offer a terse response. 1.2. What is the ratio of the Rating (1=low 6=high) of East Asia (all income levels) in 2006 to that in 2007?
Provide a succinct answer. 0.99. What is the ratio of the Rating (1=low 6=high) of Congo (Democratic) in 2006 to that in 2007?
Your answer should be compact. 1. What is the ratio of the Rating (1=low 6=high) of East Asia (all income levels) in 2006 to that in 2008?
Give a very brief answer. 0.99. What is the ratio of the Rating (1=low 6=high) in Solomon Islands in 2006 to that in 2008?
Provide a succinct answer. 0.83. What is the ratio of the Rating (1=low 6=high) in East Asia (all income levels) in 2006 to that in 2009?
Offer a very short reply. 0.99. What is the ratio of the Rating (1=low 6=high) of Central African Republic in 2006 to that in 2009?
Keep it short and to the point. 1. What is the ratio of the Rating (1=low 6=high) of Congo (Democratic) in 2006 to that in 2009?
Your response must be concise. 1.5. What is the ratio of the Rating (1=low 6=high) of East Asia (all income levels) in 2006 to that in 2010?
Offer a very short reply. 0.99. What is the ratio of the Rating (1=low 6=high) of Central African Republic in 2006 to that in 2010?
Give a very brief answer. 1. What is the ratio of the Rating (1=low 6=high) of Central African Republic in 2006 to that in 2011?
Make the answer very short. 1. What is the ratio of the Rating (1=low 6=high) of Solomon Islands in 2006 to that in 2012?
Your answer should be compact. 0.83. What is the ratio of the Rating (1=low 6=high) of Central African Republic in 2007 to that in 2008?
Keep it short and to the point. 1. What is the ratio of the Rating (1=low 6=high) in Congo (Democratic) in 2007 to that in 2008?
Your response must be concise. 1.5. What is the ratio of the Rating (1=low 6=high) of Solomon Islands in 2007 to that in 2008?
Offer a very short reply. 0.83. What is the ratio of the Rating (1=low 6=high) in East Asia (all income levels) in 2007 to that in 2009?
Make the answer very short. 1. What is the ratio of the Rating (1=low 6=high) in Congo (Democratic) in 2007 to that in 2009?
Offer a terse response. 1.5. What is the ratio of the Rating (1=low 6=high) in Solomon Islands in 2007 to that in 2009?
Keep it short and to the point. 1. What is the ratio of the Rating (1=low 6=high) in East Asia (all income levels) in 2007 to that in 2010?
Offer a very short reply. 1. What is the ratio of the Rating (1=low 6=high) of Solomon Islands in 2007 to that in 2010?
Your answer should be very brief. 1. What is the ratio of the Rating (1=low 6=high) in East Asia (all income levels) in 2007 to that in 2011?
Keep it short and to the point. 1.03. What is the ratio of the Rating (1=low 6=high) of East Asia (all income levels) in 2007 to that in 2012?
Your answer should be very brief. 1.05. What is the ratio of the Rating (1=low 6=high) of Congo (Democratic) in 2007 to that in 2012?
Ensure brevity in your answer.  1.2. What is the ratio of the Rating (1=low 6=high) of Solomon Islands in 2007 to that in 2012?
Make the answer very short. 0.83. What is the ratio of the Rating (1=low 6=high) of East Asia (all income levels) in 2008 to that in 2009?
Offer a very short reply. 1. What is the ratio of the Rating (1=low 6=high) of Solomon Islands in 2008 to that in 2009?
Make the answer very short. 1.2. What is the ratio of the Rating (1=low 6=high) of East Asia (all income levels) in 2008 to that in 2010?
Keep it short and to the point. 1. What is the ratio of the Rating (1=low 6=high) in Congo (Democratic) in 2008 to that in 2010?
Your response must be concise. 1. What is the ratio of the Rating (1=low 6=high) of Solomon Islands in 2008 to that in 2010?
Your answer should be compact. 1.2. What is the ratio of the Rating (1=low 6=high) of East Asia (all income levels) in 2008 to that in 2011?
Make the answer very short. 1.03. What is the ratio of the Rating (1=low 6=high) of Congo (Democratic) in 2008 to that in 2011?
Give a very brief answer. 0.8. What is the ratio of the Rating (1=low 6=high) of Solomon Islands in 2008 to that in 2011?
Make the answer very short. 1. What is the ratio of the Rating (1=low 6=high) of East Asia (all income levels) in 2008 to that in 2012?
Your answer should be compact. 1.05. What is the ratio of the Rating (1=low 6=high) in Central African Republic in 2008 to that in 2012?
Offer a terse response. 1. What is the ratio of the Rating (1=low 6=high) of Congo (Democratic) in 2008 to that in 2012?
Your answer should be compact. 0.8. What is the ratio of the Rating (1=low 6=high) of Solomon Islands in 2008 to that in 2012?
Offer a very short reply. 1. What is the ratio of the Rating (1=low 6=high) in East Asia (all income levels) in 2009 to that in 2010?
Your answer should be compact. 1. What is the ratio of the Rating (1=low 6=high) of Congo (Democratic) in 2009 to that in 2010?
Offer a very short reply. 1. What is the ratio of the Rating (1=low 6=high) of Solomon Islands in 2009 to that in 2010?
Your answer should be compact. 1. What is the ratio of the Rating (1=low 6=high) in East Asia (all income levels) in 2009 to that in 2011?
Keep it short and to the point. 1.03. What is the ratio of the Rating (1=low 6=high) of Central African Republic in 2009 to that in 2011?
Give a very brief answer. 1. What is the ratio of the Rating (1=low 6=high) in Congo (Democratic) in 2009 to that in 2011?
Make the answer very short. 0.8. What is the ratio of the Rating (1=low 6=high) of East Asia (all income levels) in 2009 to that in 2012?
Give a very brief answer. 1.05. What is the ratio of the Rating (1=low 6=high) of Central African Republic in 2009 to that in 2012?
Provide a succinct answer. 1. What is the ratio of the Rating (1=low 6=high) in Solomon Islands in 2009 to that in 2012?
Your response must be concise. 0.83. What is the ratio of the Rating (1=low 6=high) of East Asia (all income levels) in 2010 to that in 2011?
Keep it short and to the point. 1.03. What is the ratio of the Rating (1=low 6=high) of Central African Republic in 2010 to that in 2011?
Offer a very short reply. 1. What is the ratio of the Rating (1=low 6=high) in East Asia (all income levels) in 2010 to that in 2012?
Your answer should be very brief. 1.05. What is the ratio of the Rating (1=low 6=high) in Central African Republic in 2010 to that in 2012?
Your answer should be very brief. 1. What is the ratio of the Rating (1=low 6=high) of East Asia (all income levels) in 2011 to that in 2012?
Offer a terse response. 1.02. What is the ratio of the Rating (1=low 6=high) in Central African Republic in 2011 to that in 2012?
Keep it short and to the point. 1. What is the ratio of the Rating (1=low 6=high) in Congo (Democratic) in 2011 to that in 2012?
Provide a short and direct response. 1. What is the ratio of the Rating (1=low 6=high) of Solomon Islands in 2011 to that in 2012?
Offer a terse response. 1. What is the difference between the highest and the second highest Rating (1=low 6=high) in East Asia (all income levels)?
Keep it short and to the point. 0.14. What is the difference between the highest and the second highest Rating (1=low 6=high) in Central African Republic?
Your answer should be very brief. 0. What is the difference between the highest and the second highest Rating (1=low 6=high) in Congo (Democratic)?
Ensure brevity in your answer.  0. What is the difference between the highest and the second highest Rating (1=low 6=high) in Solomon Islands?
Give a very brief answer. 0. What is the difference between the highest and the lowest Rating (1=low 6=high) in East Asia (all income levels)?
Make the answer very short. 0.29. 